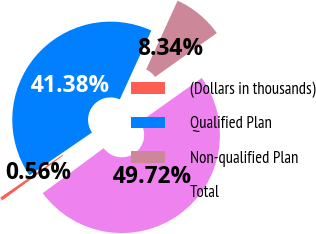<chart> <loc_0><loc_0><loc_500><loc_500><pie_chart><fcel>(Dollars in thousands)<fcel>Qualified Plan<fcel>Non-qualified Plan<fcel>Total<nl><fcel>0.56%<fcel>41.38%<fcel>8.34%<fcel>49.72%<nl></chart> 